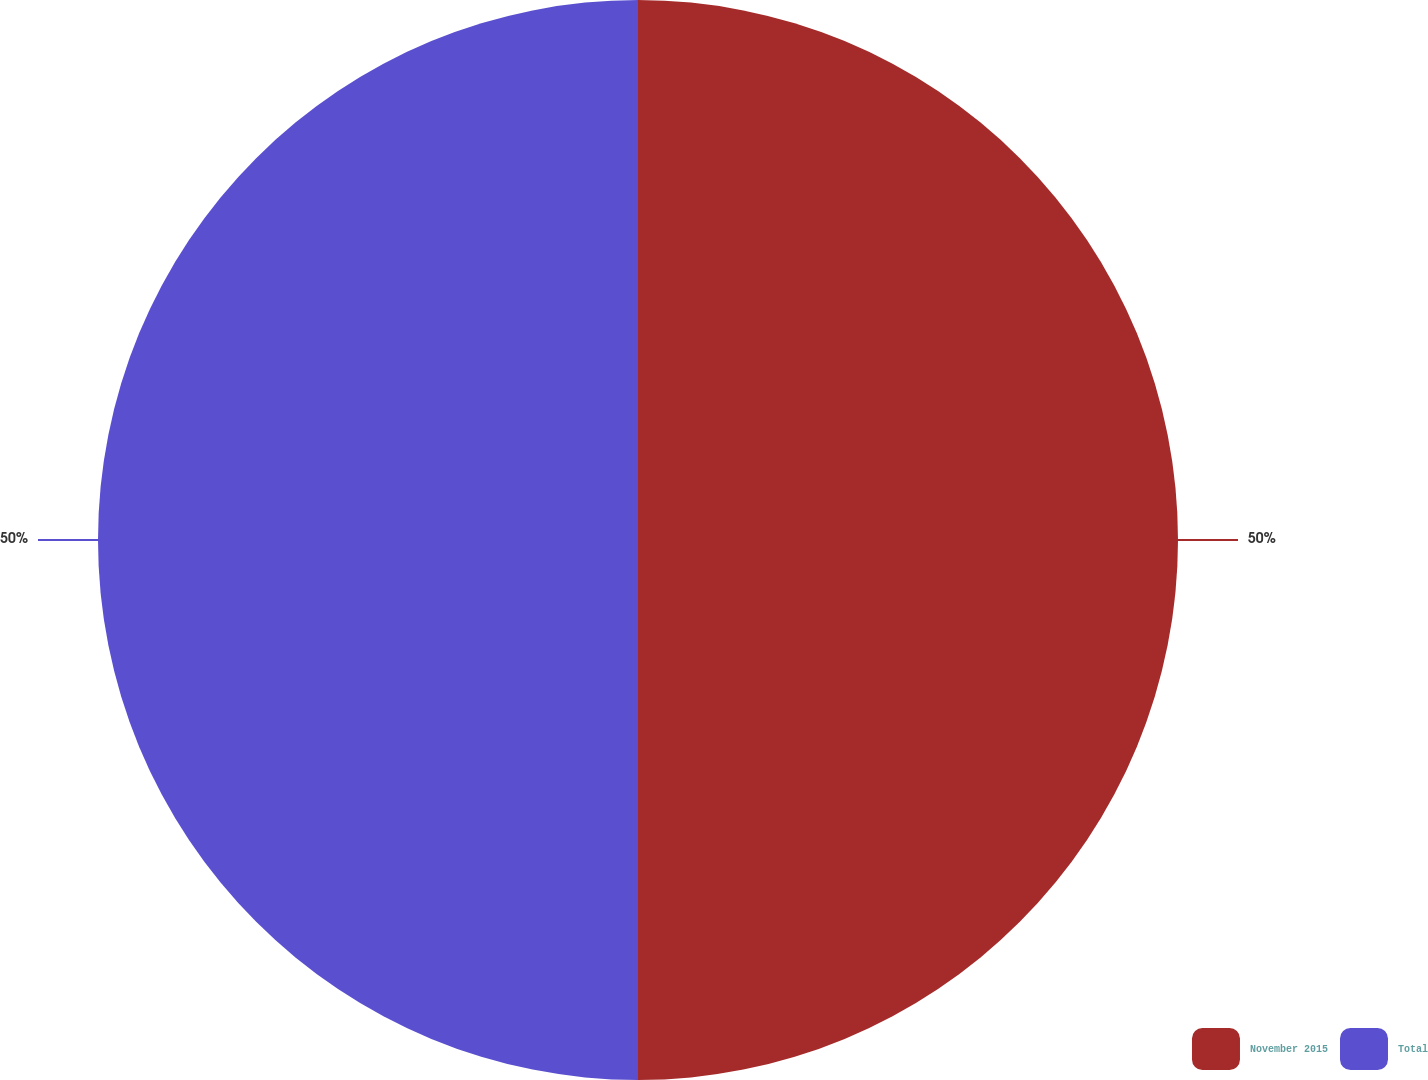<chart> <loc_0><loc_0><loc_500><loc_500><pie_chart><fcel>November 2015<fcel>Total<nl><fcel>50.0%<fcel>50.0%<nl></chart> 